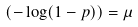Convert formula to latex. <formula><loc_0><loc_0><loc_500><loc_500>( - \log ( 1 - p ) ) = \mu</formula> 